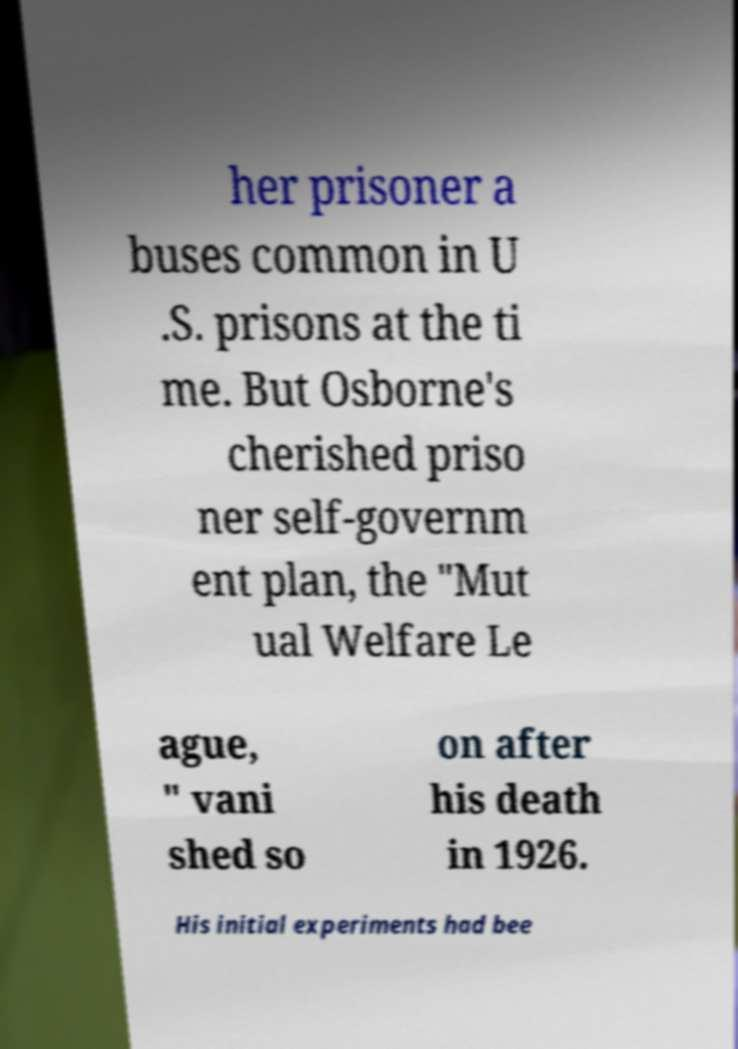What messages or text are displayed in this image? I need them in a readable, typed format. her prisoner a buses common in U .S. prisons at the ti me. But Osborne's cherished priso ner self-governm ent plan, the "Mut ual Welfare Le ague, " vani shed so on after his death in 1926. His initial experiments had bee 